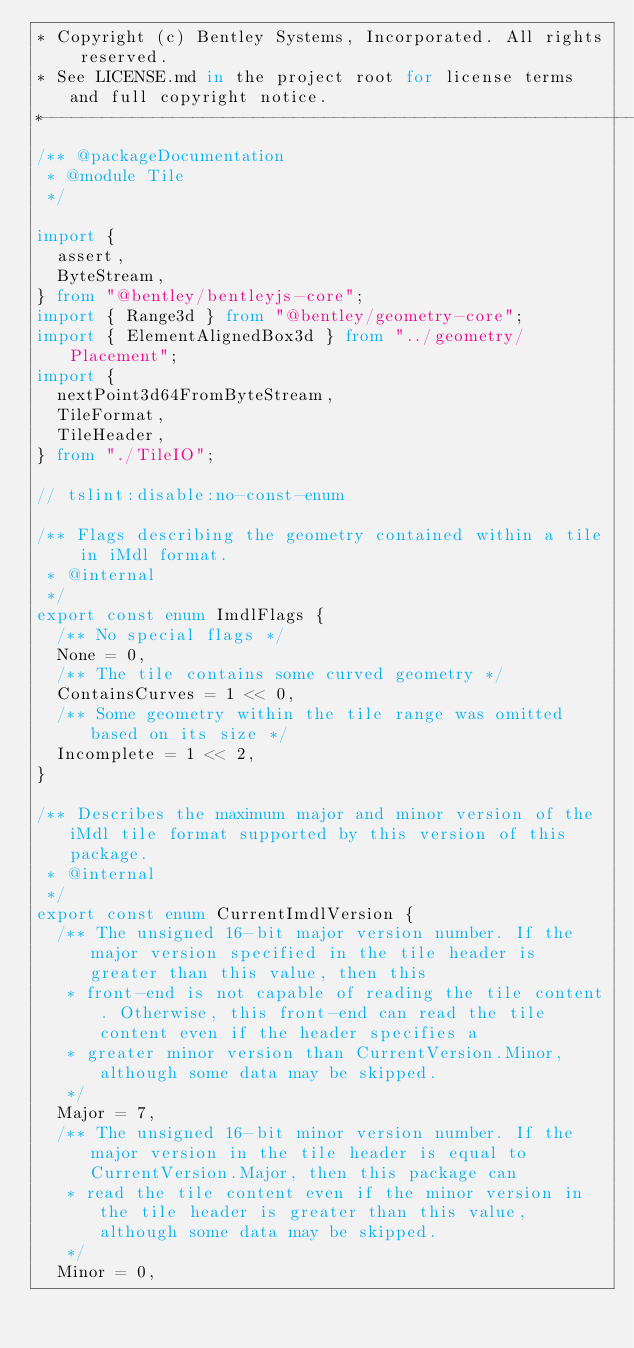Convert code to text. <code><loc_0><loc_0><loc_500><loc_500><_TypeScript_>* Copyright (c) Bentley Systems, Incorporated. All rights reserved.
* See LICENSE.md in the project root for license terms and full copyright notice.
*--------------------------------------------------------------------------------------------*/
/** @packageDocumentation
 * @module Tile
 */

import {
  assert,
  ByteStream,
} from "@bentley/bentleyjs-core";
import { Range3d } from "@bentley/geometry-core";
import { ElementAlignedBox3d } from "../geometry/Placement";
import {
  nextPoint3d64FromByteStream,
  TileFormat,
  TileHeader,
} from "./TileIO";

// tslint:disable:no-const-enum

/** Flags describing the geometry contained within a tile in iMdl format.
 * @internal
 */
export const enum ImdlFlags {
  /** No special flags */
  None = 0,
  /** The tile contains some curved geometry */
  ContainsCurves = 1 << 0,
  /** Some geometry within the tile range was omitted based on its size */
  Incomplete = 1 << 2,
}

/** Describes the maximum major and minor version of the iMdl tile format supported by this version of this package.
 * @internal
 */
export const enum CurrentImdlVersion {
  /** The unsigned 16-bit major version number. If the major version specified in the tile header is greater than this value, then this
   * front-end is not capable of reading the tile content. Otherwise, this front-end can read the tile content even if the header specifies a
   * greater minor version than CurrentVersion.Minor, although some data may be skipped.
   */
  Major = 7,
  /** The unsigned 16-bit minor version number. If the major version in the tile header is equal to CurrentVersion.Major, then this package can
   * read the tile content even if the minor version in the tile header is greater than this value, although some data may be skipped.
   */
  Minor = 0,</code> 